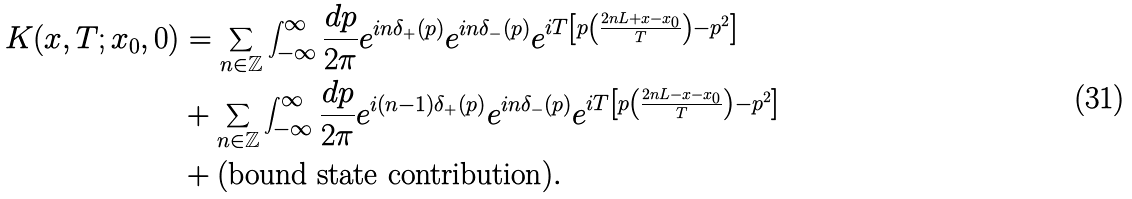<formula> <loc_0><loc_0><loc_500><loc_500>K ( x , T ; x _ { 0 } , 0 ) & = \sum _ { n \in \mathbb { Z } } \int _ { - \infty } ^ { \infty } \frac { d p } { 2 \pi } e ^ { i n \delta _ { + } ( p ) } e ^ { i n \delta _ { - } ( p ) } e ^ { i T \left [ p \left ( \frac { 2 n L + x - x _ { 0 } } { T } \right ) - p ^ { 2 } \right ] } \\ & + \sum _ { n \in \mathbb { Z } } \int _ { - \infty } ^ { \infty } \frac { d p } { 2 \pi } e ^ { i ( n - 1 ) \delta _ { + } ( p ) } e ^ { i n \delta _ { - } ( p ) } e ^ { i T \left [ p \left ( \frac { 2 n L - x - x _ { 0 } } { T } \right ) - p ^ { 2 } \right ] } \\ & + ( \text {bound state contribution} ) .</formula> 